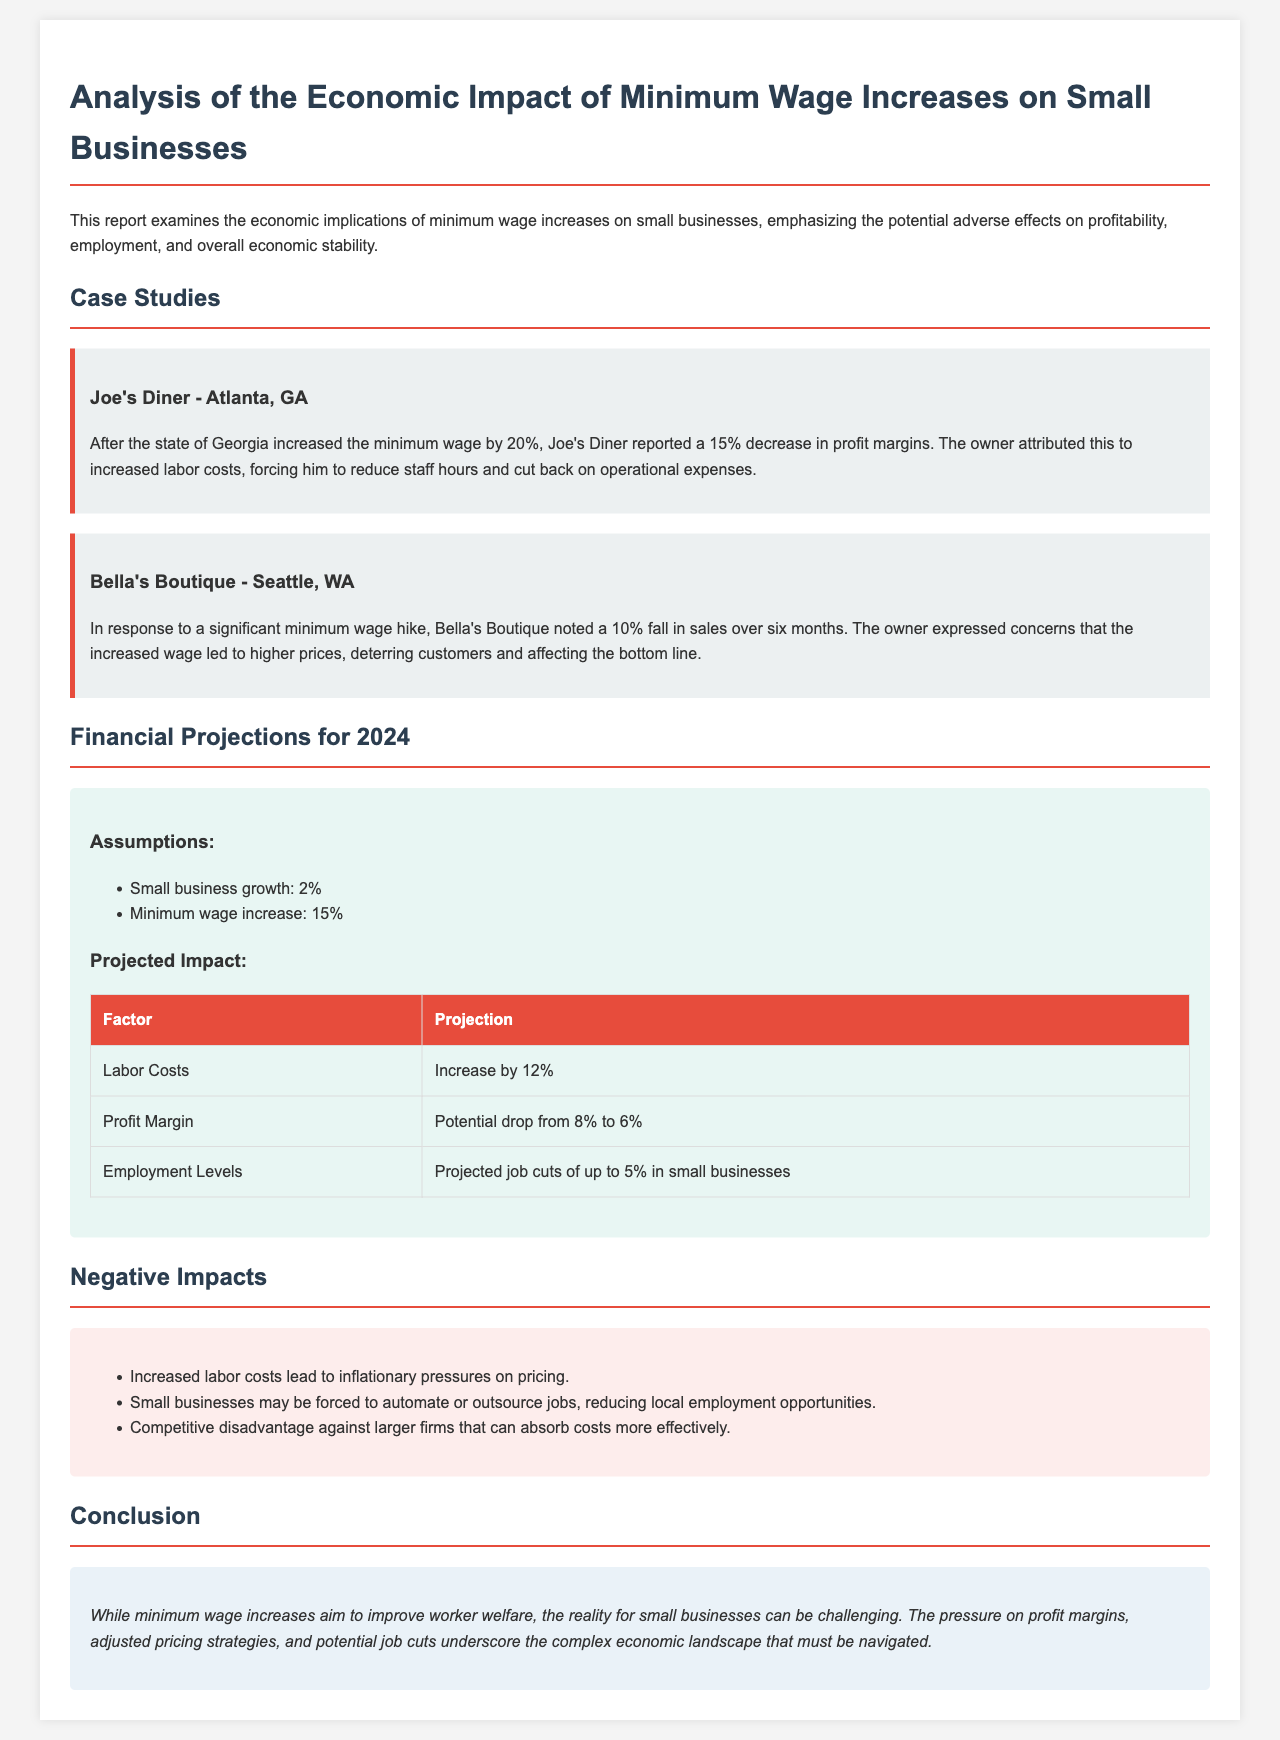What was Joe's Diner's profit margin decrease? Joe's Diner reported a 15% decrease in profit margins after the wage increase.
Answer: 15% What was Bella's Boutique's sales decline percentage over six months? Bella's Boutique noted a 10% fall in sales over six months due to the minimum wage hike.
Answer: 10% What is the projected increase in labor costs for small businesses? The report projects an increase in labor costs by 12% as a result of the minimum wage hike.
Answer: 12% What is the expected job cut percentage in small businesses? The report indicates a projected job cut of up to 5% in small businesses due to increased labor costs.
Answer: 5% What is the projected profit margin drop from 2023 to 2024? The profit margin is projected to drop from 8% to 6% following minimum wage increases.
Answer: From 8% to 6% What overarching theme does the report emphasize regarding minimum wage increases? The report emphasizes the potential adverse effects on profitability, employment, and overall economic stability for small businesses.
Answer: Adverse effects on profitability, employment, and stability Which state did Joe's Diner operate in? Joe's Diner is located in Atlanta, GA, which is where it experienced the wage increase impact.
Answer: Atlanta, GA What is the overall aim of minimum wage increases mentioned in the report? The overall aim of minimum wage increases is to improve worker welfare, though it challenges small businesses.
Answer: Improve worker welfare 